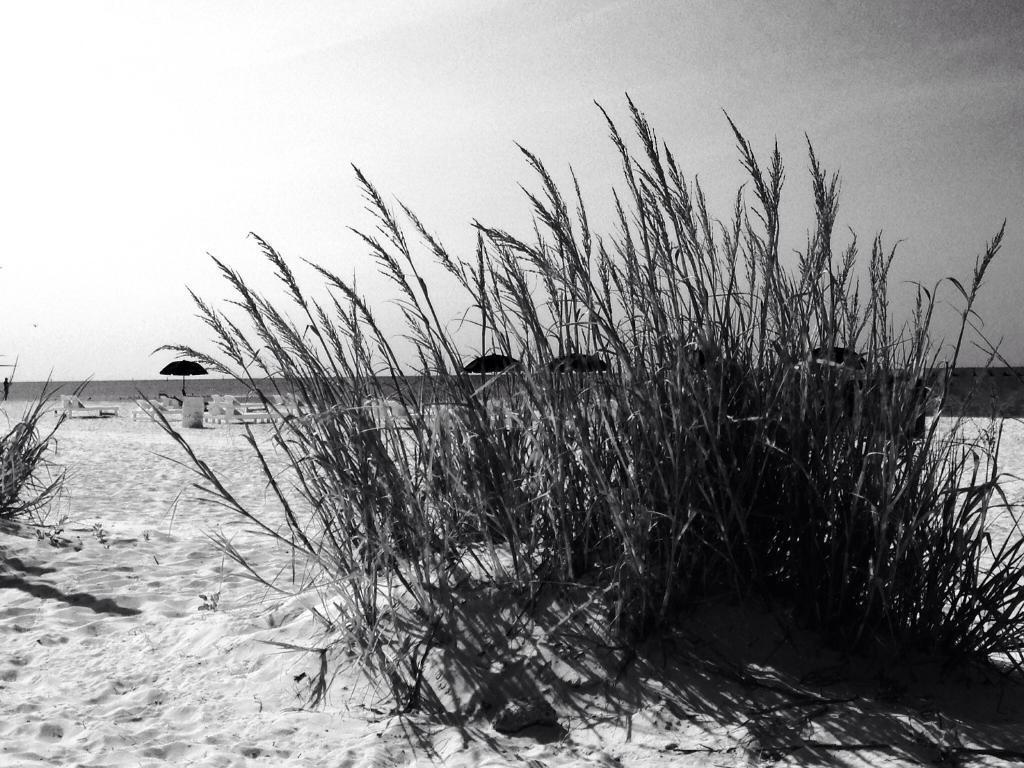How would you summarize this image in a sentence or two? This is a black and white image. In this image we can see plants. In the back there are umbrellas and few other objects. Also there is a wall. In the background there is sky. 